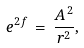<formula> <loc_0><loc_0><loc_500><loc_500>e ^ { 2 f } \, = \, \frac { A ^ { 2 } } { r ^ { 2 } } ,</formula> 